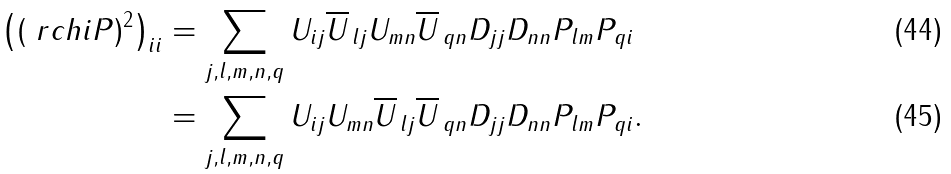<formula> <loc_0><loc_0><loc_500><loc_500>\left ( ( \ r c h i P ) ^ { 2 } \right ) _ { i i } & = \sum _ { j , l , m , n , q } U _ { i j } \overline { U } _ { \, l j } U _ { m n } \overline { U } _ { \, q n } D _ { j j } D _ { n n } P _ { l m } P _ { q i } \\ & = \sum _ { j , l , m , n , q } U _ { i j } U _ { m n } \overline { U } _ { \, l j } \overline { U } _ { \, q n } D _ { j j } D _ { n n } P _ { l m } P _ { q i } .</formula> 